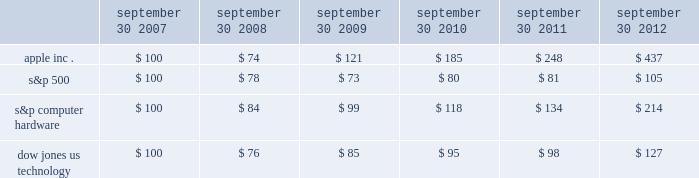Company stock performance the following graph shows a five-year comparison of cumulative total shareholder return , calculated on a dividend reinvested basis , for the company , the s&p 500 composite index , the s&p computer hardware index , and the dow jones u.s .
Technology index .
The graph assumes $ 100 was invested in each of the company 2019s common stock , the s&p 500 composite index , the s&p computer hardware index , and the dow jones u.s .
Technology index as of the market close on september 30 , 2007 .
Data points on the graph are annual .
Note that historic stock price performance is not necessarily indicative of future stock price performance .
Sep-11sep-10sep-09sep-08sep-07 sep-12 apple inc .
S&p 500 s&p computer hardware dow jones us technology comparison of 5 year cumulative total return* among apple inc. , the s&p 500 index , the s&p computer hardware index , and the dow jones us technology index *$ 100 invested on 9/30/07 in stock or index , including reinvestment of dividends .
Fiscal year ending september 30 .
Copyright a9 2012 s&p , a division of the mcgraw-hill companies inc .
All rights reserved .
September 30 , september 30 , september 30 , september 30 , september 30 , september 30 .

What was the percentage 5 year cumulative total return for apple inc . for the the period ended september 30 , 2012? 
Computations: ((437 - 100) / 100)
Answer: 3.37. 